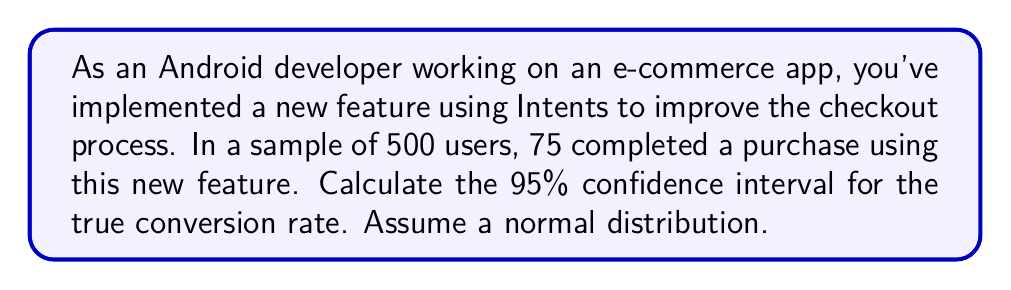Give your solution to this math problem. Let's approach this step-by-step:

1. Identify the key information:
   - Sample size (n) = 500
   - Number of successes (x) = 75
   - Confidence level = 95% (z-score = 1.96)

2. Calculate the sample proportion (p̂):
   $$\hat{p} = \frac{x}{n} = \frac{75}{500} = 0.15$$

3. Calculate the standard error (SE):
   $$SE = \sqrt{\frac{\hat{p}(1-\hat{p})}{n}} = \sqrt{\frac{0.15(1-0.15)}{500}} = 0.0159$$

4. The formula for the confidence interval is:
   $$\hat{p} \pm z \cdot SE$$

   Where z is the z-score for the desired confidence level (1.96 for 95%)

5. Calculate the margin of error:
   $$\text{Margin of Error} = 1.96 \cdot 0.0159 = 0.0312$$

6. Calculate the lower and upper bounds of the confidence interval:
   Lower bound: $0.15 - 0.0312 = 0.1188$
   Upper bound: $0.15 + 0.0312 = 0.1812$

Therefore, we can say with 95% confidence that the true conversion rate lies between 11.88% and 18.12%.
Answer: (0.1188, 0.1812) or 11.88% to 18.12% 